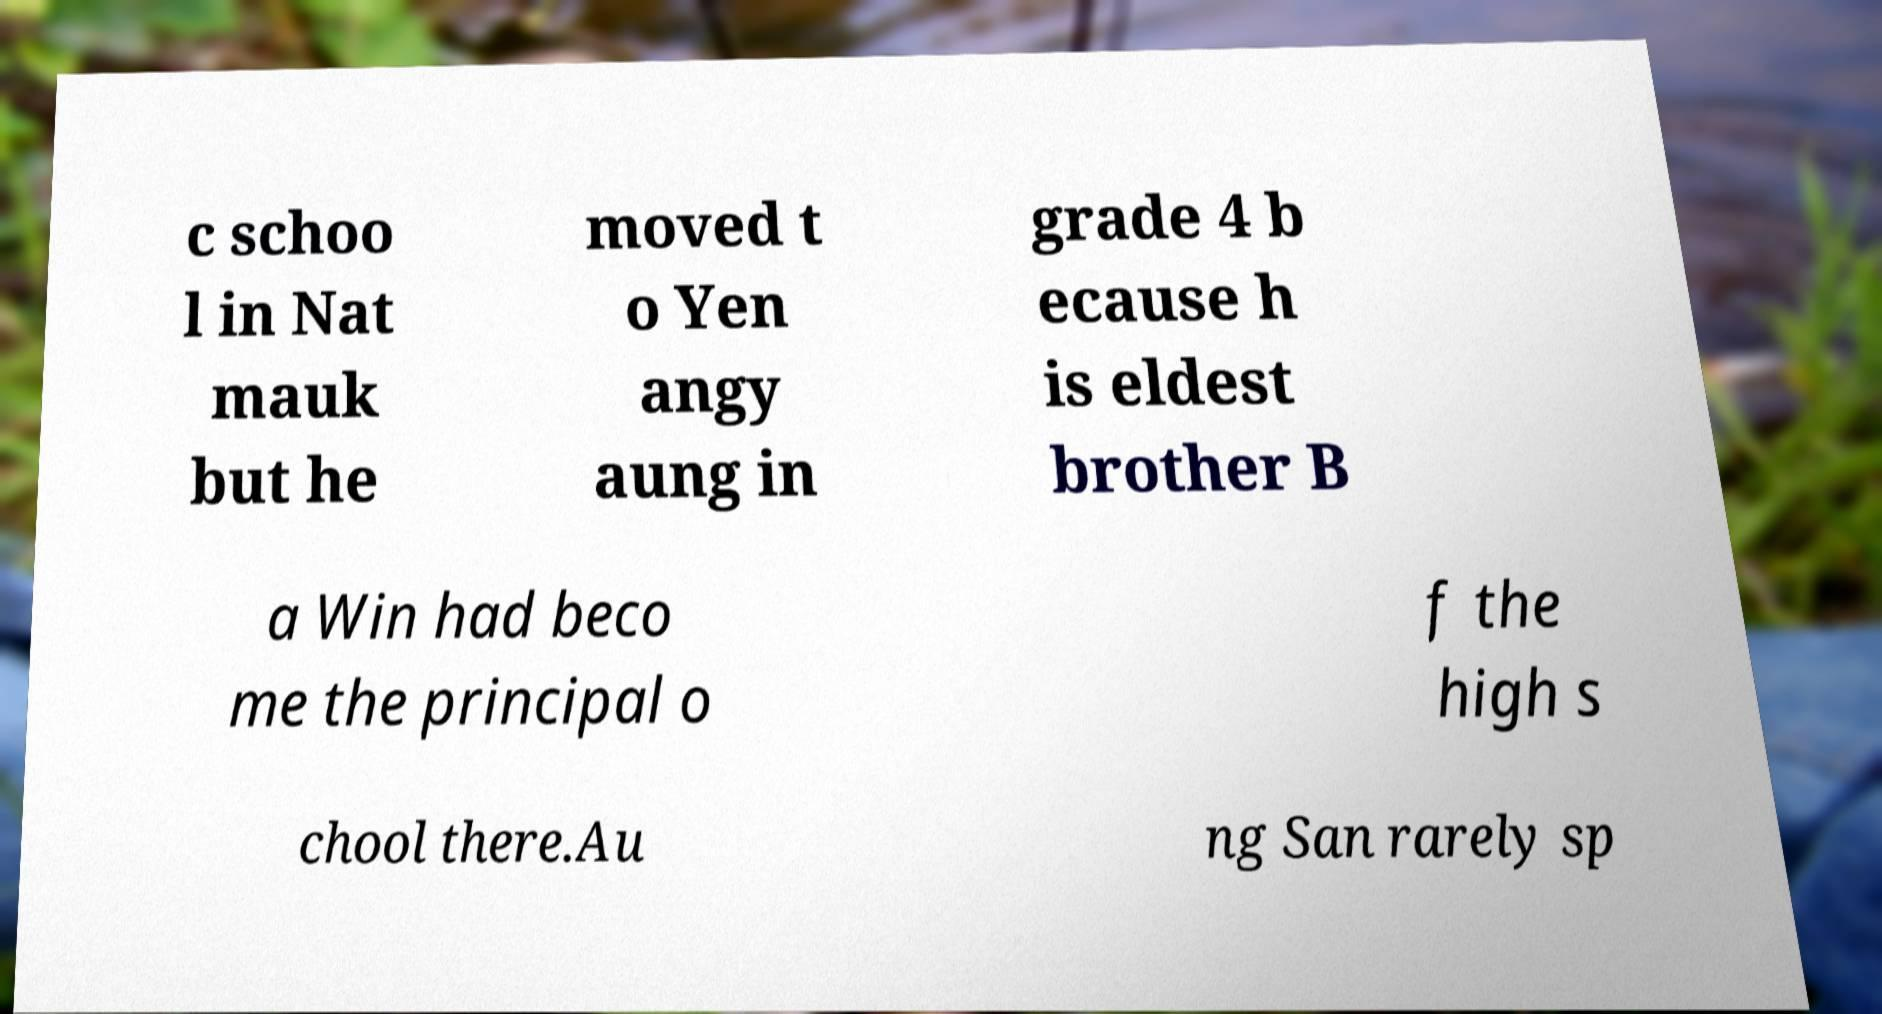Can you accurately transcribe the text from the provided image for me? c schoo l in Nat mauk but he moved t o Yen angy aung in grade 4 b ecause h is eldest brother B a Win had beco me the principal o f the high s chool there.Au ng San rarely sp 